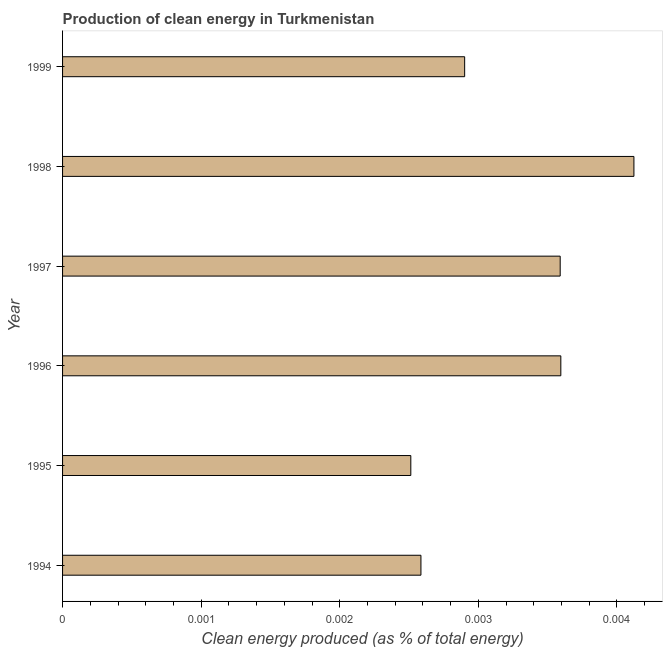Does the graph contain grids?
Offer a very short reply. No. What is the title of the graph?
Your answer should be compact. Production of clean energy in Turkmenistan. What is the label or title of the X-axis?
Your answer should be very brief. Clean energy produced (as % of total energy). What is the label or title of the Y-axis?
Offer a very short reply. Year. What is the production of clean energy in 1995?
Your response must be concise. 0. Across all years, what is the maximum production of clean energy?
Keep it short and to the point. 0. Across all years, what is the minimum production of clean energy?
Offer a very short reply. 0. In which year was the production of clean energy maximum?
Provide a short and direct response. 1998. What is the sum of the production of clean energy?
Offer a terse response. 0.02. What is the difference between the production of clean energy in 1994 and 1996?
Provide a short and direct response. -0. What is the average production of clean energy per year?
Your response must be concise. 0. What is the median production of clean energy?
Give a very brief answer. 0. In how many years, is the production of clean energy greater than 0.0012 %?
Offer a terse response. 6. Do a majority of the years between 1995 and 1994 (inclusive) have production of clean energy greater than 0.003 %?
Offer a very short reply. No. What is the ratio of the production of clean energy in 1998 to that in 1999?
Provide a short and direct response. 1.42. Is the difference between the production of clean energy in 1996 and 1997 greater than the difference between any two years?
Your answer should be compact. No. In how many years, is the production of clean energy greater than the average production of clean energy taken over all years?
Provide a short and direct response. 3. How many bars are there?
Offer a terse response. 6. How many years are there in the graph?
Provide a succinct answer. 6. What is the Clean energy produced (as % of total energy) of 1994?
Give a very brief answer. 0. What is the Clean energy produced (as % of total energy) in 1995?
Provide a short and direct response. 0. What is the Clean energy produced (as % of total energy) of 1996?
Give a very brief answer. 0. What is the Clean energy produced (as % of total energy) of 1997?
Offer a terse response. 0. What is the Clean energy produced (as % of total energy) of 1998?
Ensure brevity in your answer.  0. What is the Clean energy produced (as % of total energy) in 1999?
Your answer should be compact. 0. What is the difference between the Clean energy produced (as % of total energy) in 1994 and 1995?
Keep it short and to the point. 7e-5. What is the difference between the Clean energy produced (as % of total energy) in 1994 and 1996?
Your answer should be very brief. -0. What is the difference between the Clean energy produced (as % of total energy) in 1994 and 1997?
Your answer should be compact. -0. What is the difference between the Clean energy produced (as % of total energy) in 1994 and 1998?
Give a very brief answer. -0. What is the difference between the Clean energy produced (as % of total energy) in 1994 and 1999?
Provide a short and direct response. -0. What is the difference between the Clean energy produced (as % of total energy) in 1995 and 1996?
Provide a succinct answer. -0. What is the difference between the Clean energy produced (as % of total energy) in 1995 and 1997?
Provide a succinct answer. -0. What is the difference between the Clean energy produced (as % of total energy) in 1995 and 1998?
Offer a very short reply. -0. What is the difference between the Clean energy produced (as % of total energy) in 1995 and 1999?
Your answer should be very brief. -0. What is the difference between the Clean energy produced (as % of total energy) in 1996 and 1997?
Offer a terse response. 0. What is the difference between the Clean energy produced (as % of total energy) in 1996 and 1998?
Offer a terse response. -0. What is the difference between the Clean energy produced (as % of total energy) in 1996 and 1999?
Your answer should be very brief. 0. What is the difference between the Clean energy produced (as % of total energy) in 1997 and 1998?
Your response must be concise. -0. What is the difference between the Clean energy produced (as % of total energy) in 1997 and 1999?
Your response must be concise. 0. What is the difference between the Clean energy produced (as % of total energy) in 1998 and 1999?
Your answer should be very brief. 0. What is the ratio of the Clean energy produced (as % of total energy) in 1994 to that in 1996?
Offer a very short reply. 0.72. What is the ratio of the Clean energy produced (as % of total energy) in 1994 to that in 1997?
Your answer should be very brief. 0.72. What is the ratio of the Clean energy produced (as % of total energy) in 1994 to that in 1998?
Give a very brief answer. 0.63. What is the ratio of the Clean energy produced (as % of total energy) in 1994 to that in 1999?
Offer a terse response. 0.89. What is the ratio of the Clean energy produced (as % of total energy) in 1995 to that in 1996?
Offer a very short reply. 0.7. What is the ratio of the Clean energy produced (as % of total energy) in 1995 to that in 1997?
Offer a terse response. 0.7. What is the ratio of the Clean energy produced (as % of total energy) in 1995 to that in 1998?
Keep it short and to the point. 0.61. What is the ratio of the Clean energy produced (as % of total energy) in 1995 to that in 1999?
Offer a terse response. 0.87. What is the ratio of the Clean energy produced (as % of total energy) in 1996 to that in 1998?
Your answer should be very brief. 0.87. What is the ratio of the Clean energy produced (as % of total energy) in 1996 to that in 1999?
Make the answer very short. 1.24. What is the ratio of the Clean energy produced (as % of total energy) in 1997 to that in 1998?
Provide a succinct answer. 0.87. What is the ratio of the Clean energy produced (as % of total energy) in 1997 to that in 1999?
Provide a short and direct response. 1.24. What is the ratio of the Clean energy produced (as % of total energy) in 1998 to that in 1999?
Ensure brevity in your answer.  1.42. 